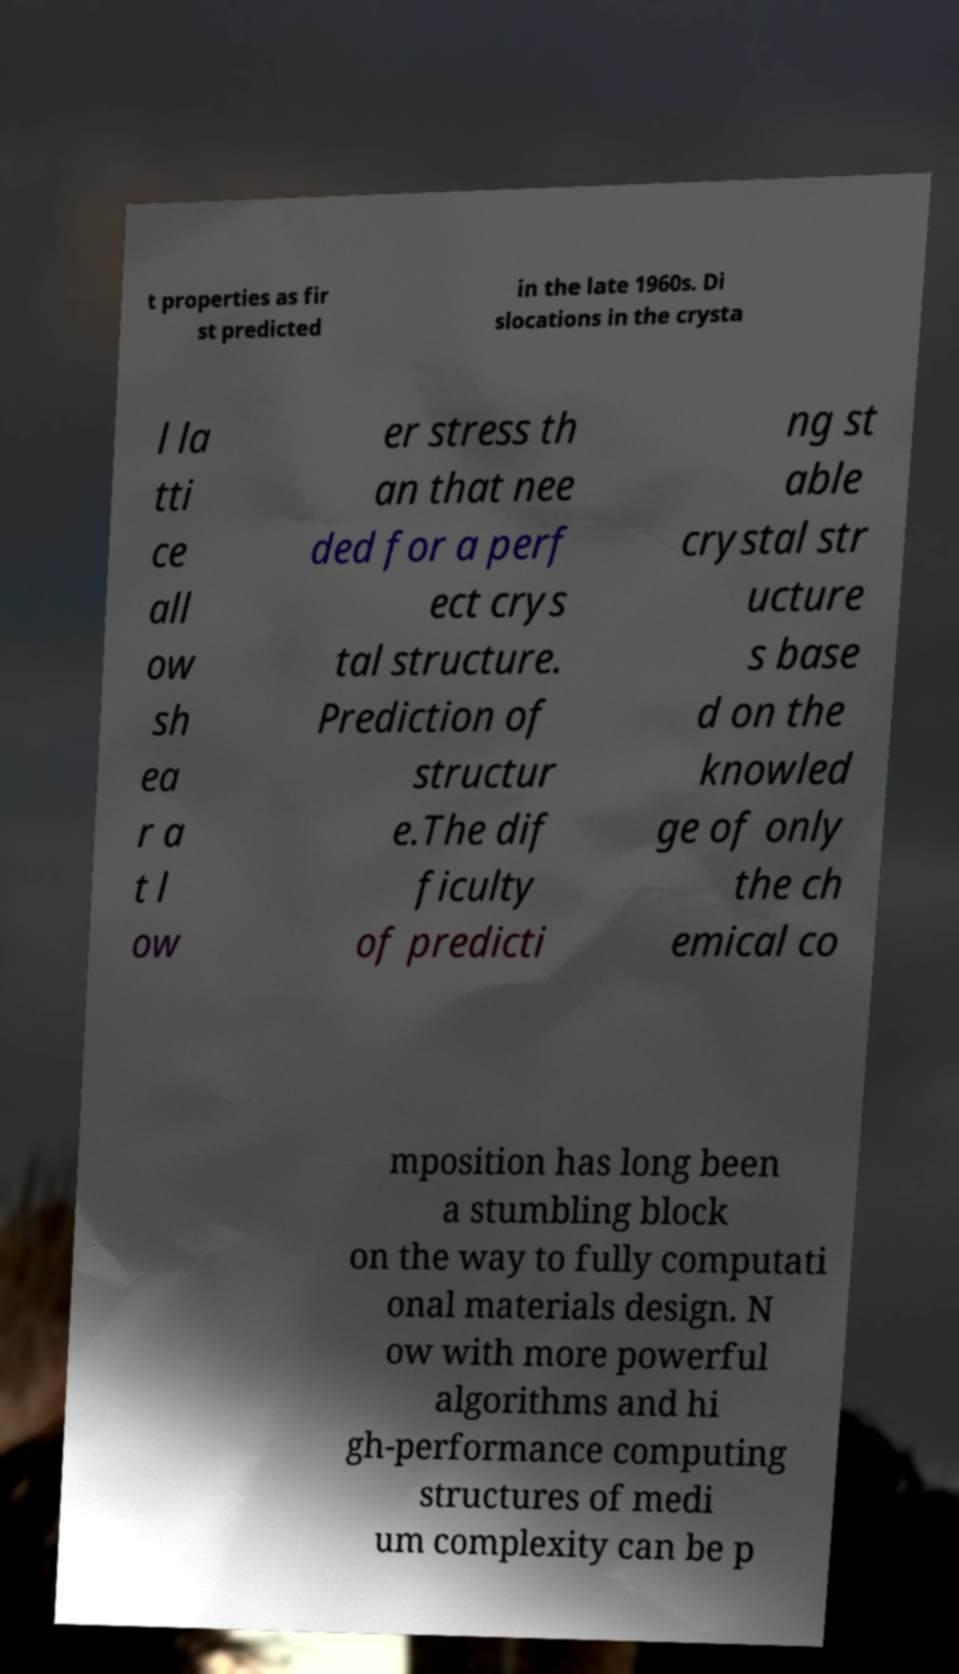I need the written content from this picture converted into text. Can you do that? t properties as fir st predicted in the late 1960s. Di slocations in the crysta l la tti ce all ow sh ea r a t l ow er stress th an that nee ded for a perf ect crys tal structure. Prediction of structur e.The dif ficulty of predicti ng st able crystal str ucture s base d on the knowled ge of only the ch emical co mposition has long been a stumbling block on the way to fully computati onal materials design. N ow with more powerful algorithms and hi gh-performance computing structures of medi um complexity can be p 